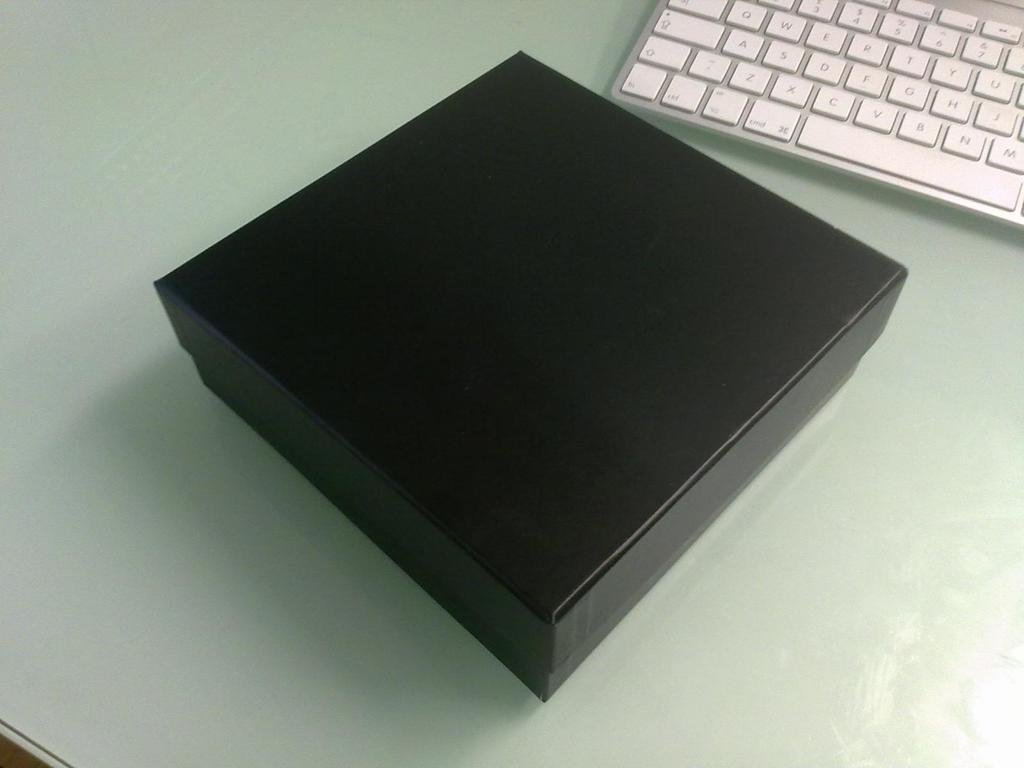<image>
Relay a brief, clear account of the picture shown. QWERTY standard keys are shown on the keyboard of this laptop. 